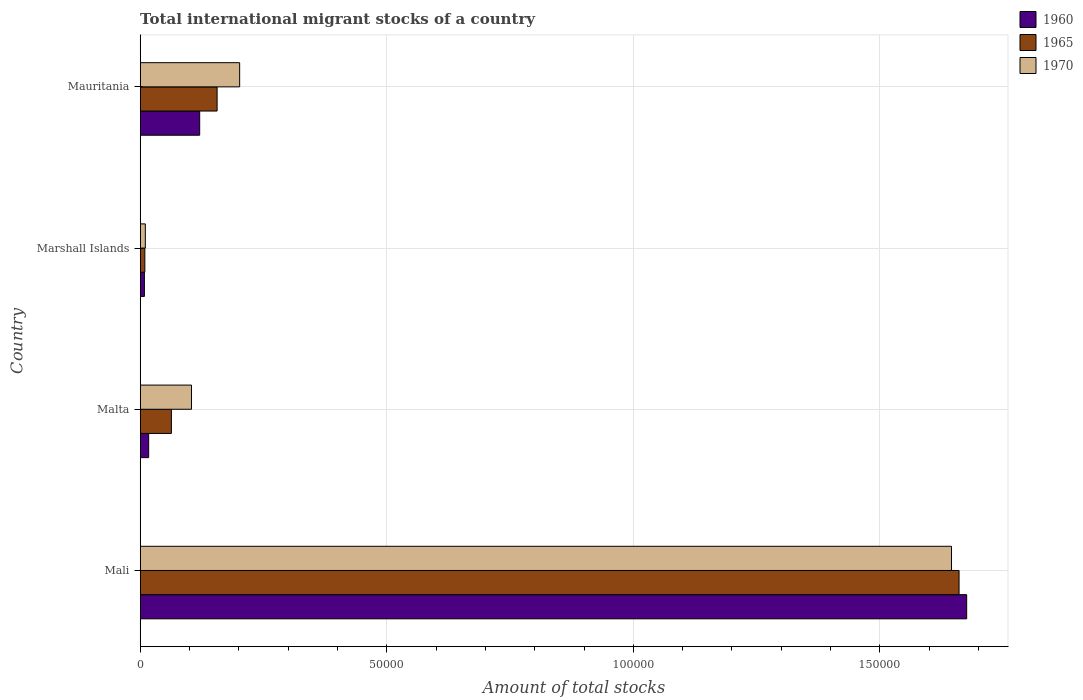How many different coloured bars are there?
Ensure brevity in your answer.  3. Are the number of bars per tick equal to the number of legend labels?
Your answer should be compact. Yes. Are the number of bars on each tick of the Y-axis equal?
Ensure brevity in your answer.  Yes. How many bars are there on the 4th tick from the top?
Provide a short and direct response. 3. What is the label of the 3rd group of bars from the top?
Give a very brief answer. Malta. In how many cases, is the number of bars for a given country not equal to the number of legend labels?
Provide a short and direct response. 0. What is the amount of total stocks in in 1965 in Mauritania?
Make the answer very short. 1.56e+04. Across all countries, what is the maximum amount of total stocks in in 1970?
Ensure brevity in your answer.  1.65e+05. Across all countries, what is the minimum amount of total stocks in in 1970?
Provide a short and direct response. 1035. In which country was the amount of total stocks in in 1970 maximum?
Offer a terse response. Mali. In which country was the amount of total stocks in in 1960 minimum?
Your answer should be compact. Marshall Islands. What is the total amount of total stocks in in 1965 in the graph?
Provide a short and direct response. 1.89e+05. What is the difference between the amount of total stocks in in 1970 in Mali and that in Marshall Islands?
Offer a terse response. 1.63e+05. What is the difference between the amount of total stocks in in 1970 in Marshall Islands and the amount of total stocks in in 1965 in Malta?
Your answer should be compact. -5285. What is the average amount of total stocks in in 1965 per country?
Your response must be concise. 4.72e+04. What is the difference between the amount of total stocks in in 1960 and amount of total stocks in in 1970 in Mauritania?
Your answer should be very brief. -8105. In how many countries, is the amount of total stocks in in 1960 greater than 100000 ?
Your response must be concise. 1. What is the ratio of the amount of total stocks in in 1960 in Mali to that in Malta?
Offer a terse response. 97.9. Is the amount of total stocks in in 1965 in Marshall Islands less than that in Mauritania?
Make the answer very short. Yes. Is the difference between the amount of total stocks in in 1960 in Malta and Mauritania greater than the difference between the amount of total stocks in in 1970 in Malta and Mauritania?
Your response must be concise. No. What is the difference between the highest and the second highest amount of total stocks in in 1960?
Make the answer very short. 1.56e+05. What is the difference between the highest and the lowest amount of total stocks in in 1970?
Your response must be concise. 1.63e+05. In how many countries, is the amount of total stocks in in 1960 greater than the average amount of total stocks in in 1960 taken over all countries?
Provide a short and direct response. 1. What does the 2nd bar from the top in Malta represents?
Give a very brief answer. 1965. How many bars are there?
Your answer should be compact. 12. How many countries are there in the graph?
Make the answer very short. 4. What is the difference between two consecutive major ticks on the X-axis?
Make the answer very short. 5.00e+04. Does the graph contain any zero values?
Offer a very short reply. No. How many legend labels are there?
Your answer should be very brief. 3. What is the title of the graph?
Offer a terse response. Total international migrant stocks of a country. What is the label or title of the X-axis?
Make the answer very short. Amount of total stocks. What is the label or title of the Y-axis?
Provide a succinct answer. Country. What is the Amount of total stocks of 1960 in Mali?
Your response must be concise. 1.68e+05. What is the Amount of total stocks in 1965 in Mali?
Offer a very short reply. 1.66e+05. What is the Amount of total stocks of 1970 in Mali?
Your response must be concise. 1.65e+05. What is the Amount of total stocks of 1960 in Malta?
Offer a terse response. 1712. What is the Amount of total stocks in 1965 in Malta?
Give a very brief answer. 6320. What is the Amount of total stocks in 1970 in Malta?
Provide a succinct answer. 1.04e+04. What is the Amount of total stocks in 1960 in Marshall Islands?
Give a very brief answer. 846. What is the Amount of total stocks of 1965 in Marshall Islands?
Provide a succinct answer. 936. What is the Amount of total stocks in 1970 in Marshall Islands?
Offer a terse response. 1035. What is the Amount of total stocks of 1960 in Mauritania?
Ensure brevity in your answer.  1.21e+04. What is the Amount of total stocks of 1965 in Mauritania?
Your response must be concise. 1.56e+04. What is the Amount of total stocks in 1970 in Mauritania?
Provide a succinct answer. 2.02e+04. Across all countries, what is the maximum Amount of total stocks in 1960?
Your answer should be compact. 1.68e+05. Across all countries, what is the maximum Amount of total stocks in 1965?
Offer a very short reply. 1.66e+05. Across all countries, what is the maximum Amount of total stocks in 1970?
Keep it short and to the point. 1.65e+05. Across all countries, what is the minimum Amount of total stocks of 1960?
Offer a terse response. 846. Across all countries, what is the minimum Amount of total stocks in 1965?
Offer a terse response. 936. Across all countries, what is the minimum Amount of total stocks in 1970?
Offer a terse response. 1035. What is the total Amount of total stocks of 1960 in the graph?
Your answer should be compact. 1.82e+05. What is the total Amount of total stocks of 1965 in the graph?
Offer a very short reply. 1.89e+05. What is the total Amount of total stocks of 1970 in the graph?
Offer a terse response. 1.96e+05. What is the difference between the Amount of total stocks of 1960 in Mali and that in Malta?
Offer a very short reply. 1.66e+05. What is the difference between the Amount of total stocks of 1965 in Mali and that in Malta?
Provide a short and direct response. 1.60e+05. What is the difference between the Amount of total stocks of 1970 in Mali and that in Malta?
Your answer should be very brief. 1.54e+05. What is the difference between the Amount of total stocks of 1960 in Mali and that in Marshall Islands?
Your response must be concise. 1.67e+05. What is the difference between the Amount of total stocks of 1965 in Mali and that in Marshall Islands?
Your answer should be very brief. 1.65e+05. What is the difference between the Amount of total stocks of 1970 in Mali and that in Marshall Islands?
Give a very brief answer. 1.63e+05. What is the difference between the Amount of total stocks of 1960 in Mali and that in Mauritania?
Your response must be concise. 1.56e+05. What is the difference between the Amount of total stocks of 1965 in Mali and that in Mauritania?
Your answer should be compact. 1.50e+05. What is the difference between the Amount of total stocks in 1970 in Mali and that in Mauritania?
Your answer should be very brief. 1.44e+05. What is the difference between the Amount of total stocks in 1960 in Malta and that in Marshall Islands?
Give a very brief answer. 866. What is the difference between the Amount of total stocks of 1965 in Malta and that in Marshall Islands?
Provide a short and direct response. 5384. What is the difference between the Amount of total stocks of 1970 in Malta and that in Marshall Islands?
Offer a very short reply. 9366. What is the difference between the Amount of total stocks in 1960 in Malta and that in Mauritania?
Offer a terse response. -1.03e+04. What is the difference between the Amount of total stocks in 1965 in Malta and that in Mauritania?
Your response must be concise. -9272. What is the difference between the Amount of total stocks in 1970 in Malta and that in Mauritania?
Ensure brevity in your answer.  -9762. What is the difference between the Amount of total stocks of 1960 in Marshall Islands and that in Mauritania?
Make the answer very short. -1.12e+04. What is the difference between the Amount of total stocks in 1965 in Marshall Islands and that in Mauritania?
Provide a short and direct response. -1.47e+04. What is the difference between the Amount of total stocks of 1970 in Marshall Islands and that in Mauritania?
Offer a very short reply. -1.91e+04. What is the difference between the Amount of total stocks in 1960 in Mali and the Amount of total stocks in 1965 in Malta?
Make the answer very short. 1.61e+05. What is the difference between the Amount of total stocks in 1960 in Mali and the Amount of total stocks in 1970 in Malta?
Your answer should be very brief. 1.57e+05. What is the difference between the Amount of total stocks of 1965 in Mali and the Amount of total stocks of 1970 in Malta?
Keep it short and to the point. 1.56e+05. What is the difference between the Amount of total stocks of 1960 in Mali and the Amount of total stocks of 1965 in Marshall Islands?
Provide a short and direct response. 1.67e+05. What is the difference between the Amount of total stocks of 1960 in Mali and the Amount of total stocks of 1970 in Marshall Islands?
Offer a very short reply. 1.67e+05. What is the difference between the Amount of total stocks of 1965 in Mali and the Amount of total stocks of 1970 in Marshall Islands?
Provide a short and direct response. 1.65e+05. What is the difference between the Amount of total stocks of 1960 in Mali and the Amount of total stocks of 1965 in Mauritania?
Provide a short and direct response. 1.52e+05. What is the difference between the Amount of total stocks in 1960 in Mali and the Amount of total stocks in 1970 in Mauritania?
Your answer should be very brief. 1.47e+05. What is the difference between the Amount of total stocks of 1965 in Mali and the Amount of total stocks of 1970 in Mauritania?
Your answer should be compact. 1.46e+05. What is the difference between the Amount of total stocks of 1960 in Malta and the Amount of total stocks of 1965 in Marshall Islands?
Your answer should be compact. 776. What is the difference between the Amount of total stocks of 1960 in Malta and the Amount of total stocks of 1970 in Marshall Islands?
Your response must be concise. 677. What is the difference between the Amount of total stocks of 1965 in Malta and the Amount of total stocks of 1970 in Marshall Islands?
Offer a terse response. 5285. What is the difference between the Amount of total stocks of 1960 in Malta and the Amount of total stocks of 1965 in Mauritania?
Your response must be concise. -1.39e+04. What is the difference between the Amount of total stocks of 1960 in Malta and the Amount of total stocks of 1970 in Mauritania?
Your answer should be very brief. -1.85e+04. What is the difference between the Amount of total stocks in 1965 in Malta and the Amount of total stocks in 1970 in Mauritania?
Keep it short and to the point. -1.38e+04. What is the difference between the Amount of total stocks in 1960 in Marshall Islands and the Amount of total stocks in 1965 in Mauritania?
Ensure brevity in your answer.  -1.47e+04. What is the difference between the Amount of total stocks of 1960 in Marshall Islands and the Amount of total stocks of 1970 in Mauritania?
Make the answer very short. -1.93e+04. What is the difference between the Amount of total stocks of 1965 in Marshall Islands and the Amount of total stocks of 1970 in Mauritania?
Offer a terse response. -1.92e+04. What is the average Amount of total stocks of 1960 per country?
Make the answer very short. 4.56e+04. What is the average Amount of total stocks of 1965 per country?
Ensure brevity in your answer.  4.72e+04. What is the average Amount of total stocks in 1970 per country?
Provide a succinct answer. 4.90e+04. What is the difference between the Amount of total stocks of 1960 and Amount of total stocks of 1965 in Mali?
Ensure brevity in your answer.  1544. What is the difference between the Amount of total stocks in 1960 and Amount of total stocks in 1970 in Mali?
Your answer should be compact. 3074. What is the difference between the Amount of total stocks in 1965 and Amount of total stocks in 1970 in Mali?
Make the answer very short. 1530. What is the difference between the Amount of total stocks in 1960 and Amount of total stocks in 1965 in Malta?
Your answer should be compact. -4608. What is the difference between the Amount of total stocks of 1960 and Amount of total stocks of 1970 in Malta?
Your answer should be very brief. -8689. What is the difference between the Amount of total stocks of 1965 and Amount of total stocks of 1970 in Malta?
Provide a succinct answer. -4081. What is the difference between the Amount of total stocks in 1960 and Amount of total stocks in 1965 in Marshall Islands?
Your response must be concise. -90. What is the difference between the Amount of total stocks of 1960 and Amount of total stocks of 1970 in Marshall Islands?
Ensure brevity in your answer.  -189. What is the difference between the Amount of total stocks of 1965 and Amount of total stocks of 1970 in Marshall Islands?
Provide a short and direct response. -99. What is the difference between the Amount of total stocks of 1960 and Amount of total stocks of 1965 in Mauritania?
Make the answer very short. -3534. What is the difference between the Amount of total stocks of 1960 and Amount of total stocks of 1970 in Mauritania?
Ensure brevity in your answer.  -8105. What is the difference between the Amount of total stocks of 1965 and Amount of total stocks of 1970 in Mauritania?
Give a very brief answer. -4571. What is the ratio of the Amount of total stocks in 1960 in Mali to that in Malta?
Make the answer very short. 97.9. What is the ratio of the Amount of total stocks in 1965 in Mali to that in Malta?
Offer a very short reply. 26.27. What is the ratio of the Amount of total stocks of 1970 in Mali to that in Malta?
Provide a short and direct response. 15.82. What is the ratio of the Amount of total stocks in 1960 in Mali to that in Marshall Islands?
Give a very brief answer. 198.11. What is the ratio of the Amount of total stocks of 1965 in Mali to that in Marshall Islands?
Offer a very short reply. 177.41. What is the ratio of the Amount of total stocks in 1970 in Mali to that in Marshall Islands?
Provide a short and direct response. 158.96. What is the ratio of the Amount of total stocks of 1960 in Mali to that in Mauritania?
Offer a very short reply. 13.9. What is the ratio of the Amount of total stocks in 1965 in Mali to that in Mauritania?
Ensure brevity in your answer.  10.65. What is the ratio of the Amount of total stocks of 1970 in Mali to that in Mauritania?
Offer a terse response. 8.16. What is the ratio of the Amount of total stocks of 1960 in Malta to that in Marshall Islands?
Ensure brevity in your answer.  2.02. What is the ratio of the Amount of total stocks of 1965 in Malta to that in Marshall Islands?
Give a very brief answer. 6.75. What is the ratio of the Amount of total stocks of 1970 in Malta to that in Marshall Islands?
Ensure brevity in your answer.  10.05. What is the ratio of the Amount of total stocks in 1960 in Malta to that in Mauritania?
Make the answer very short. 0.14. What is the ratio of the Amount of total stocks in 1965 in Malta to that in Mauritania?
Offer a terse response. 0.41. What is the ratio of the Amount of total stocks of 1970 in Malta to that in Mauritania?
Offer a terse response. 0.52. What is the ratio of the Amount of total stocks of 1960 in Marshall Islands to that in Mauritania?
Offer a terse response. 0.07. What is the ratio of the Amount of total stocks in 1965 in Marshall Islands to that in Mauritania?
Give a very brief answer. 0.06. What is the ratio of the Amount of total stocks in 1970 in Marshall Islands to that in Mauritania?
Make the answer very short. 0.05. What is the difference between the highest and the second highest Amount of total stocks of 1960?
Provide a short and direct response. 1.56e+05. What is the difference between the highest and the second highest Amount of total stocks in 1965?
Give a very brief answer. 1.50e+05. What is the difference between the highest and the second highest Amount of total stocks of 1970?
Ensure brevity in your answer.  1.44e+05. What is the difference between the highest and the lowest Amount of total stocks in 1960?
Your response must be concise. 1.67e+05. What is the difference between the highest and the lowest Amount of total stocks in 1965?
Give a very brief answer. 1.65e+05. What is the difference between the highest and the lowest Amount of total stocks in 1970?
Provide a short and direct response. 1.63e+05. 